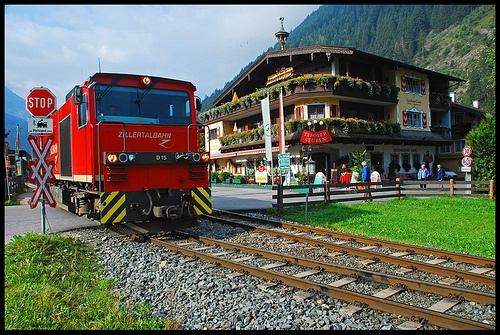Describe the objects in this image and their specific colors. I can see train in black, maroon, and navy tones, stop sign in black, brown, lightblue, and red tones, people in black, navy, lightblue, and blue tones, people in black, gray, and lightblue tones, and people in black, navy, blue, and gray tones in this image. 